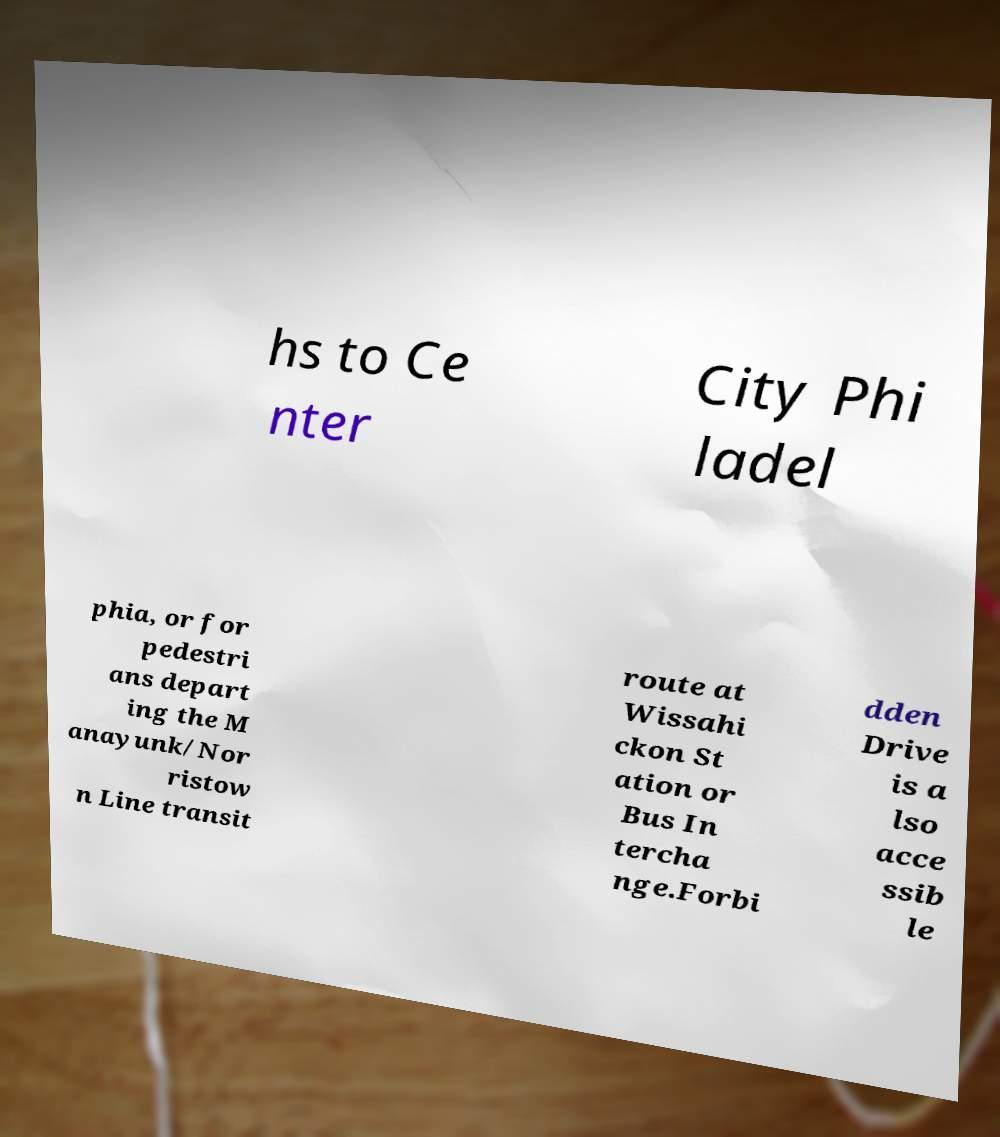Could you assist in decoding the text presented in this image and type it out clearly? hs to Ce nter City Phi ladel phia, or for pedestri ans depart ing the M anayunk/Nor ristow n Line transit route at Wissahi ckon St ation or Bus In tercha nge.Forbi dden Drive is a lso acce ssib le 